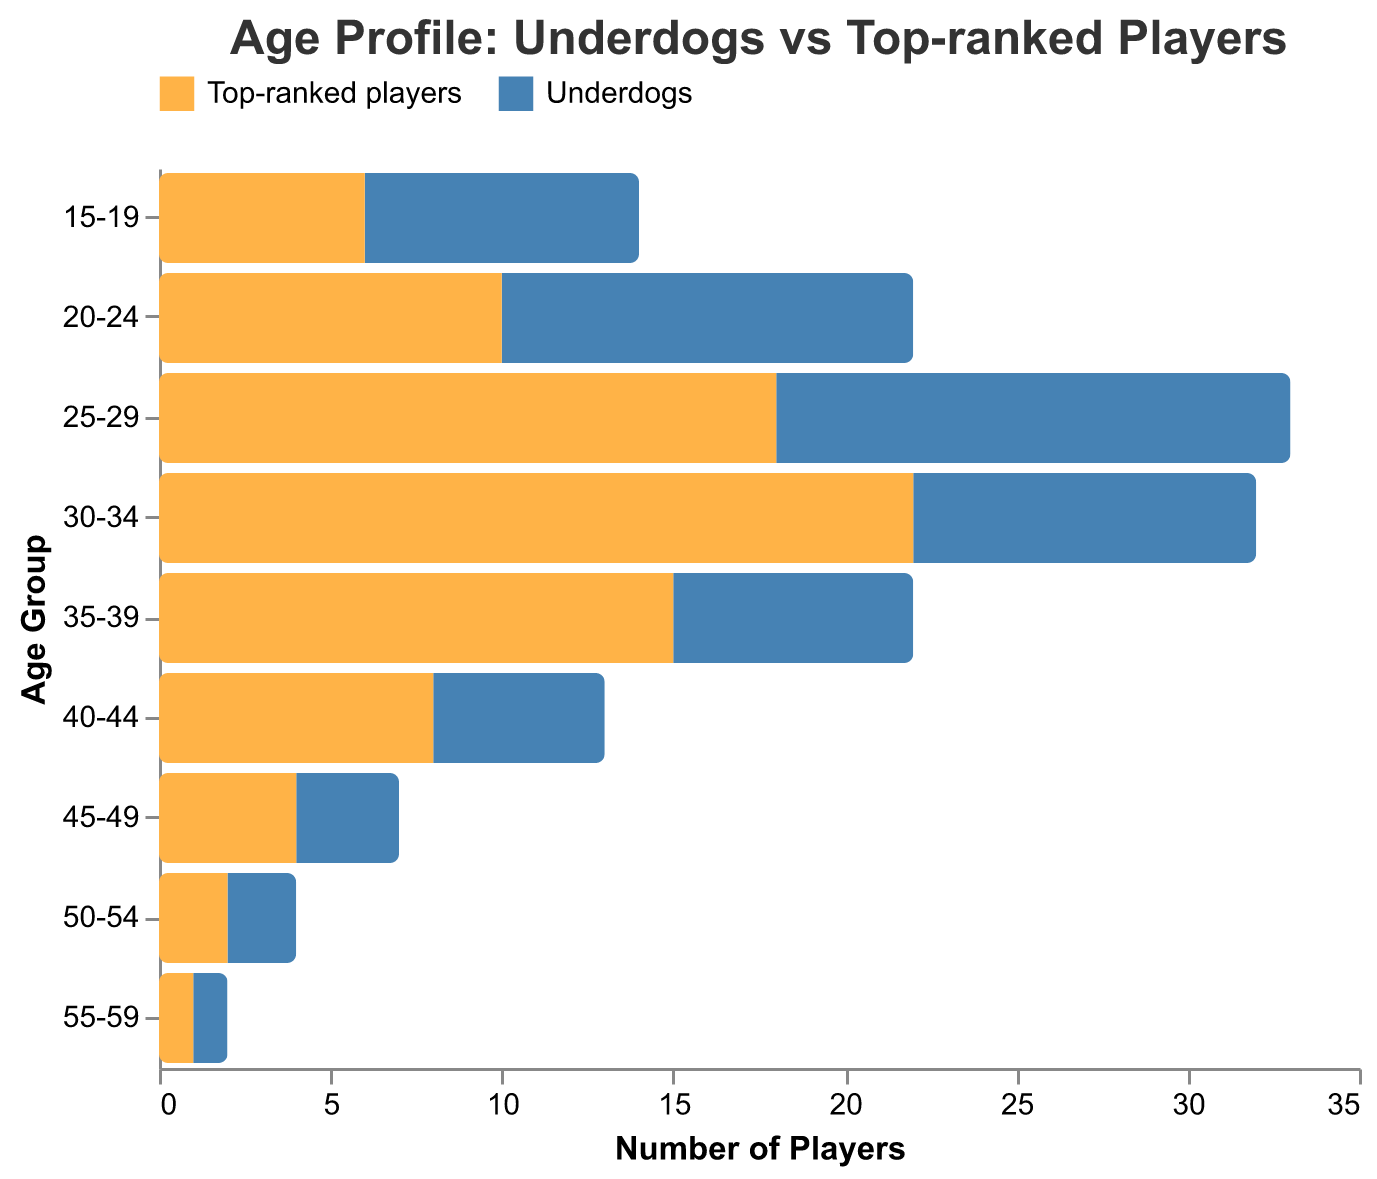What's the title of the figure? The title is typically located at the top of the figure. In this case, it reads "Age Profile: Underdogs vs Top-ranked Players" as indicated in the title configuration.
Answer: Age Profile: Underdogs vs Top-ranked Players Which age group has the highest number of underdog players? To find the highest number of underdog players, refer to the x-values for each age group under the "Underdogs" category. The highest value is 15 in the 25-29 age group.
Answer: 25-29 How many top-ranked players are in the 30-34 age group? Locate the age group 30-34 on the y-axis and refer to the "Top-ranked players" category. The value is -22. Converting this to a positive number, there are 22 top-ranked players in this age group.
Answer: 22 In which two age groups do the underdog and top-ranked player counts appear the closest? Compare the values of "Underdogs" and "Top-ranked players" for each age group. The closest values are in the 45-49 and 50-54 age groups with counts for underdogs as 3 and 2 and for top-ranked players as -4 and -2, respectively.
Answer: 45-49 and 50-54 What is the total number of players (underdogs + top-ranked) in the 15-19 age group? Add the absolute values of underdogs and top-ranked players in this group: 8 (underdogs) and 6 (top-ranked). The total is 8 + 6 = 14 players.
Answer: 14 What pattern can be observed in the count of top-ranked players as they age from 15-59? Observing the trend, the count of top-ranked players generally decreases with age, starting from -6 in the 15-19 age group to -1 in the 55-59 age group.
Answer: Decreases with age In which age group is the ratio of underdogs to top-ranked players the highest? Calculate the ratio (underdogs/top-ranked) for each age group and identify the highest. The 20-24 age group shows the highest ratio with 12 underdogs to 10 top-ranked players, resulting in a ratio of 1.2.
Answer: 20-24 